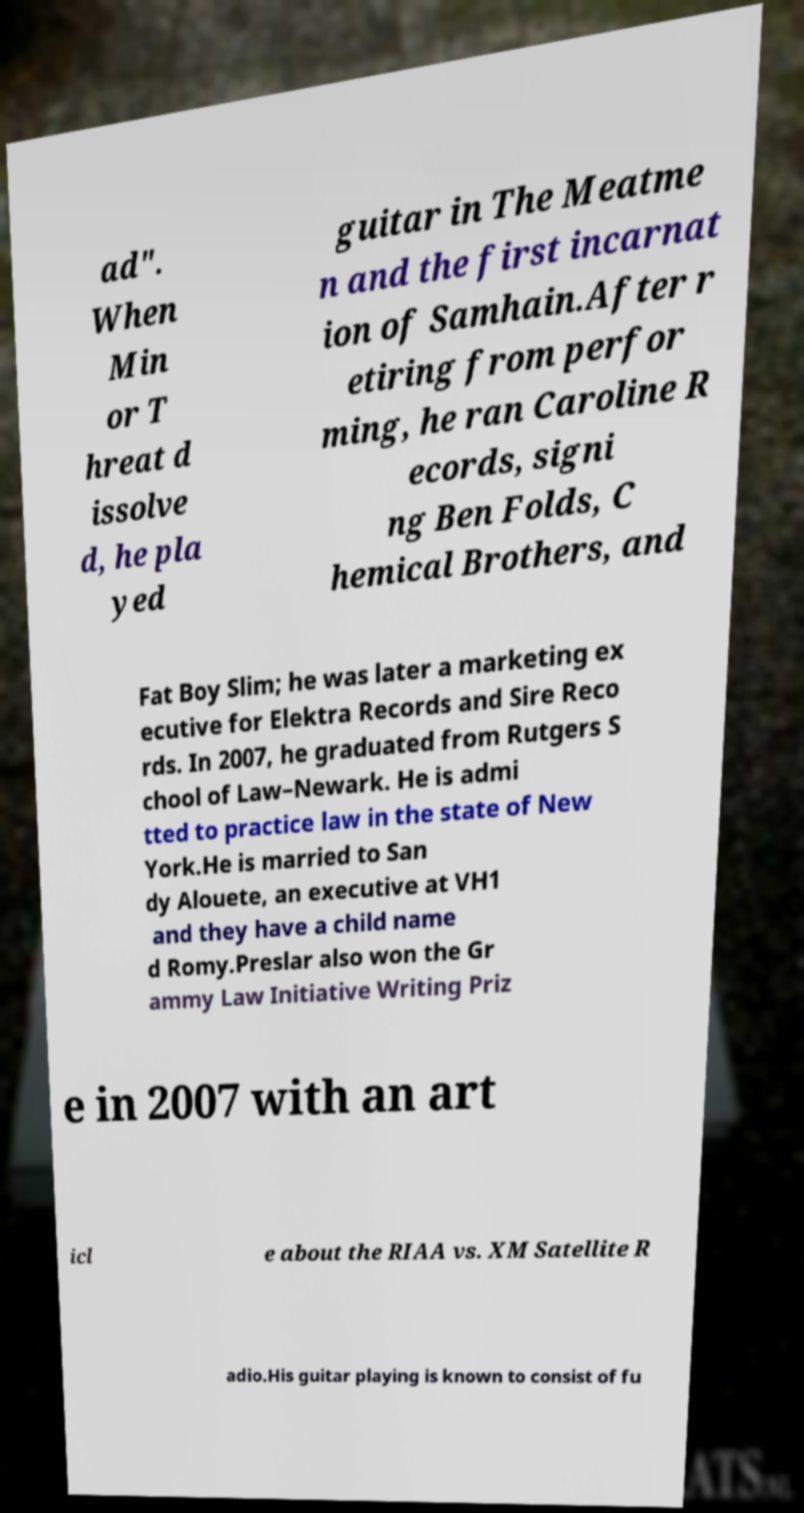Can you accurately transcribe the text from the provided image for me? ad". When Min or T hreat d issolve d, he pla yed guitar in The Meatme n and the first incarnat ion of Samhain.After r etiring from perfor ming, he ran Caroline R ecords, signi ng Ben Folds, C hemical Brothers, and Fat Boy Slim; he was later a marketing ex ecutive for Elektra Records and Sire Reco rds. In 2007, he graduated from Rutgers S chool of Law–Newark. He is admi tted to practice law in the state of New York.He is married to San dy Alouete, an executive at VH1 and they have a child name d Romy.Preslar also won the Gr ammy Law Initiative Writing Priz e in 2007 with an art icl e about the RIAA vs. XM Satellite R adio.His guitar playing is known to consist of fu 